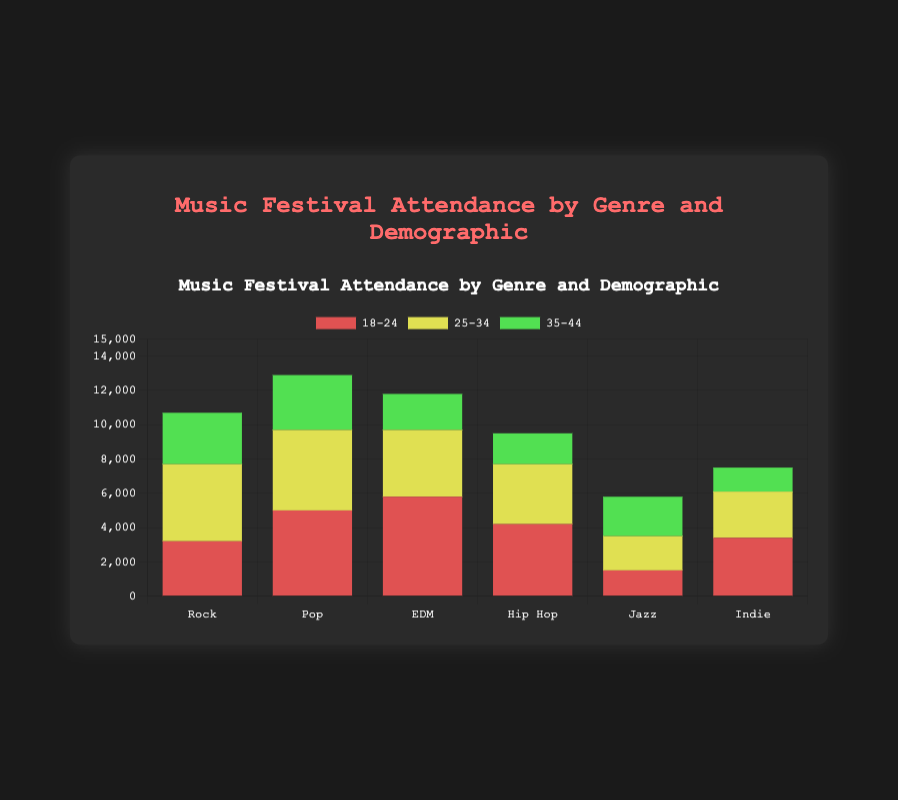What's the highest attendance for the Rock genre? To determine the highest attendance for the Rock genre, compare the attendance values for the different demographics within the Rock genre. The highest value is 4500 for the demographic 25-34.
Answer: 4500 Which genre has the highest overall attendance? To find the genre with the highest overall attendance, sum the attendance values for each genre and compare. EDM has the highest total attendance (5800+3900+2100 = 11800).
Answer: EDM Which demographic has the lowest attendance in Jazz? Compare the attendance values for each demographic within the Jazz genre. The lowest value is 1500 for the demographic 18-24.
Answer: 18-24 What is the total attendance for Pop across all demographics? Add the attendance values for the Pop genre across all demographics: 5000 (18-24) + 4700 (25-34) + 3200 (35-44) = 12900.
Answer: 12900 How does the attendance of 18-24 for Indie compare to 35-44 for Hip Hop? Compare the attendance value for Indie 18-24 (3400) with Hip Hop 35-44 (1800). Indie has higher attendance.
Answer: Indie has higher Which demographic in EDM has the second highest attendance? Rank the attendance values for EDM across demographics: 18-24 (5800), 25-34 (3900), and 35-44 (2100). The second highest is 3900 for 25-34.
Answer: 25-34 Which genre has the least total attendance and what is that total? Calculate the total attendance for each genre and identify the lowest: Jazz has the least total attendance (1500 + 2000 + 2300 = 5800).
Answer: Jazz, 5800 Between 25-34 for Rock and 25-34 for EDM, which has higher attendance? Compare the attendance values for demographic 25-34 in both genres: Rock has 4500 and EDM has 3900. Rock has higher attendance.
Answer: Rock What is the average attendance for all demographics in Hip Hop? Sum the attendance values for Hip Hop then divide by the number of demographics: (4200 + 3500 + 1800) / 3 = 9500 / 3 = 3166.67.
Answer: 3166.67 Compare the total attendance of 18-24 across all genres to the total of 35-44 across all genres. Sum the attendance values for 18-24 across all genres and 35-44 across all genres: 18-24 = 3200 + 5000 + 5800 + 4200 + 1500 + 3400 = 23100; 35-44 = 3000 + 3200 + 2100 + 1800 + 2300 + 1400 = 13800. 18-24 has higher total attendance.
Answer: 18-24 has higher 